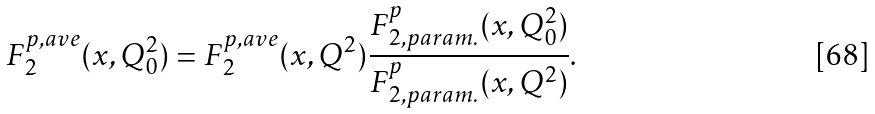Convert formula to latex. <formula><loc_0><loc_0><loc_500><loc_500>F _ { 2 } ^ { p , a v e } ( x , Q ^ { 2 } _ { 0 } ) = F _ { 2 } ^ { p , a v e } ( x , Q ^ { 2 } ) \frac { F _ { 2 , p a r a m . } ^ { p } ( x , Q ^ { 2 } _ { 0 } ) } { F _ { 2 , p a r a m . } ^ { p } ( x , Q ^ { 2 } ) } .</formula> 